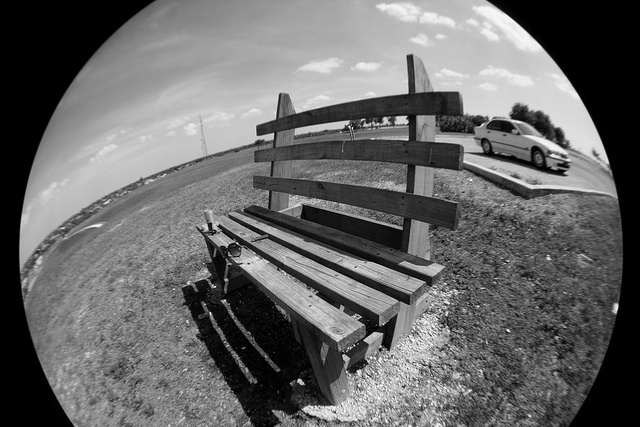Describe the objects in this image and their specific colors. I can see bench in black, darkgray, gray, and lightgray tones and car in black, gray, and lightgray tones in this image. 